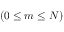<formula> <loc_0><loc_0><loc_500><loc_500>( 0 \leq m \leq N )</formula> 